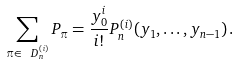<formula> <loc_0><loc_0><loc_500><loc_500>\sum _ { \pi \in \ D _ { n } ^ { ( i ) } } P _ { \pi } = \frac { y _ { 0 } ^ { i } } { i ! } P _ { n } ^ { ( i ) } ( y _ { 1 } , \dots , y _ { n - 1 } ) \, .</formula> 